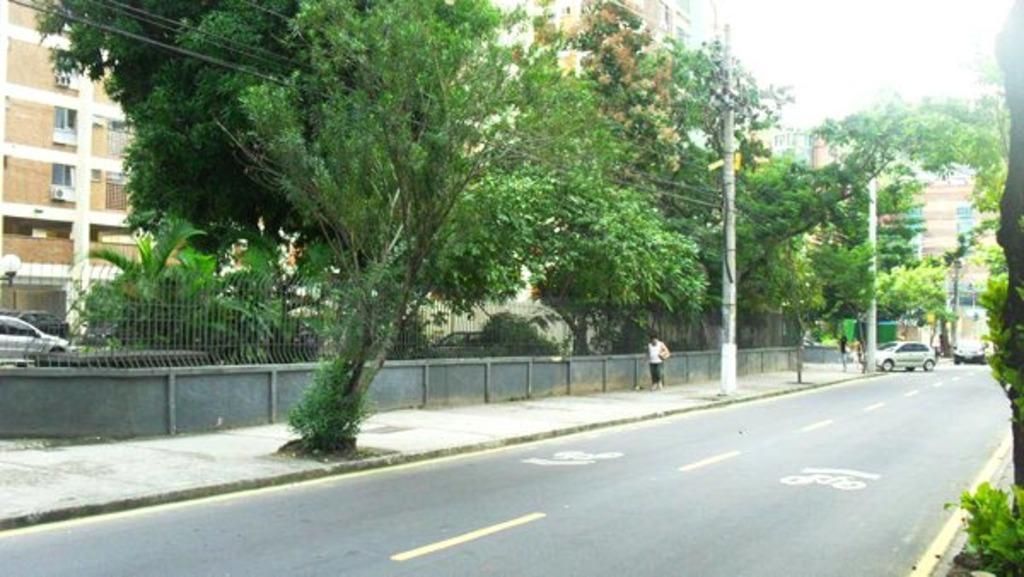How would you summarize this image in a sentence or two? In this image there is a road and we can see cars on the road. There are people and we can see a fence. In the background there are trees, poles, buildings, wires and sky. 